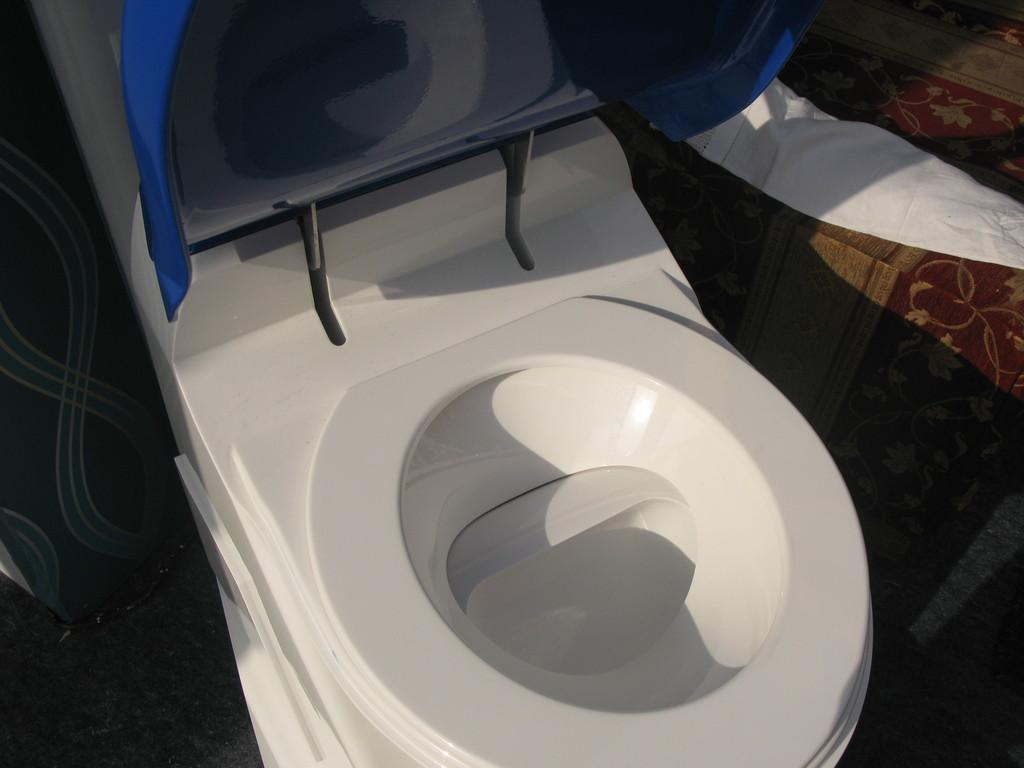What is the main object in the picture? There is a commode in the picture. Can you describe any other objects or elements in the image? There is a white-colored cloth on the floor in the top right side of the image. What direction is the tooth facing in the image? There is no tooth present in the image. Is the cork from a wine bottle visible in the image? There is no cork from a wine bottle present in the image. 